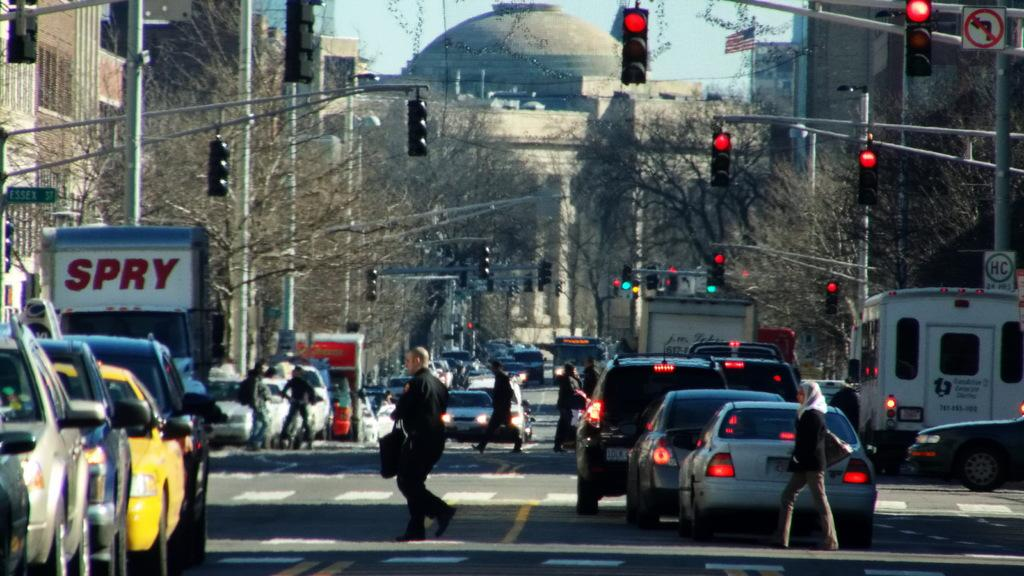Provide a one-sentence caption for the provided image. a busy street with a truck that says spry. 